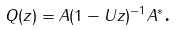<formula> <loc_0><loc_0><loc_500><loc_500>Q ( z ) = A ( 1 - U z ) ^ { - 1 } A ^ { * } \text {.}</formula> 